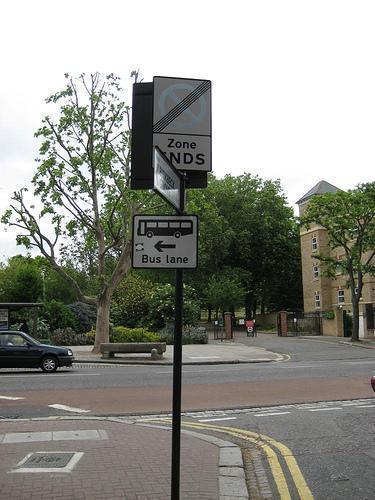What is the sign pointing to?
Pick the correct solution from the four options below to address the question.
Options: Toy boat, wrestler, baby, bus lane. Bus lane. 